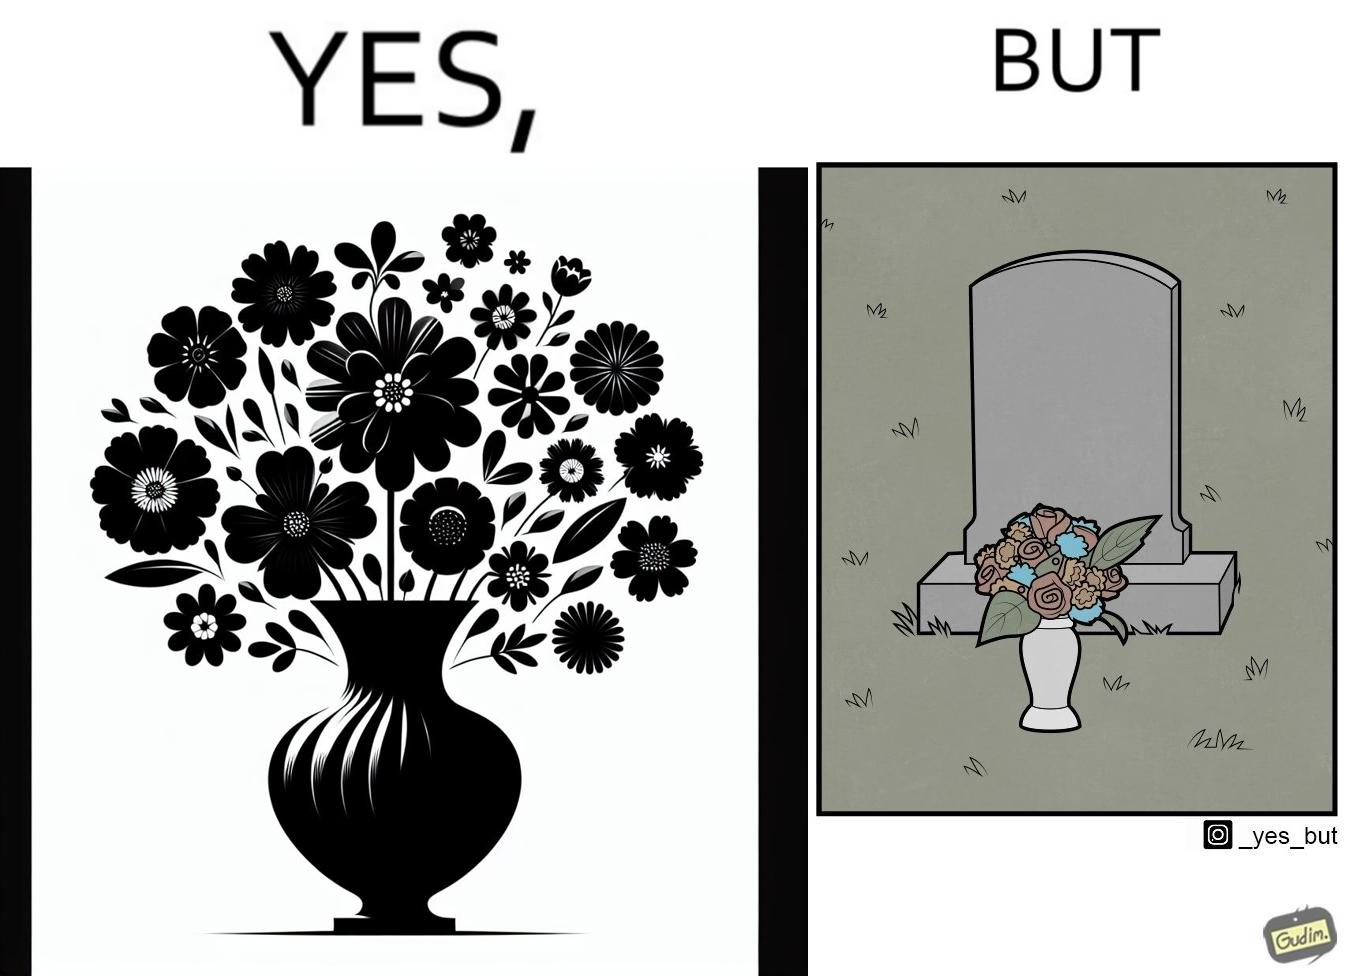What is shown in this image? The image is ironic, because in the first image a vase full of different beautiful flowers is seen which spreads a feeling of positivity, cheerfulness etc., whereas in the second image when the same vase is put in front of a grave stone it produces a feeling of sorrow 